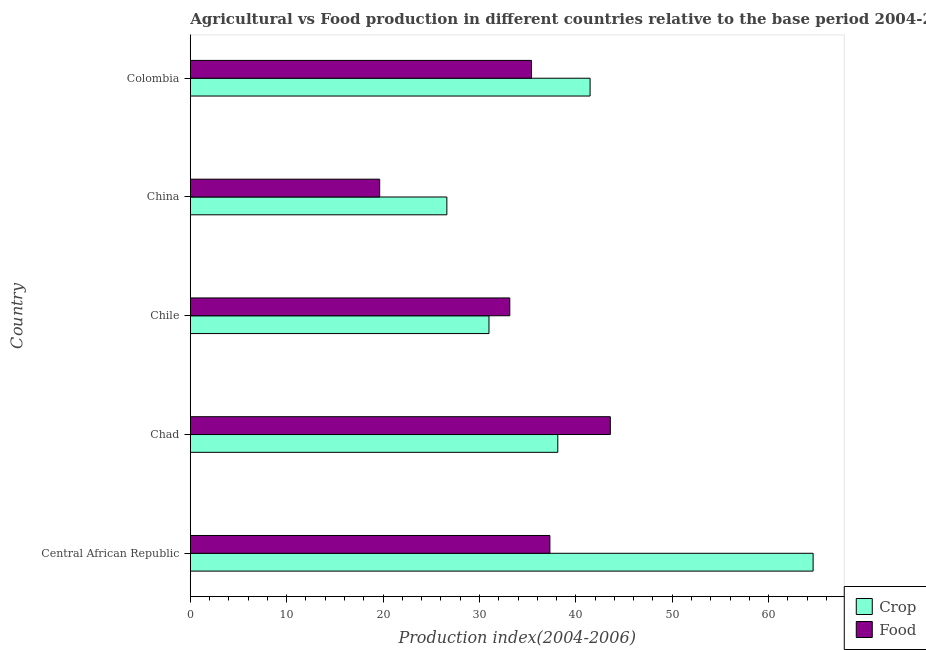How many different coloured bars are there?
Offer a very short reply. 2. How many groups of bars are there?
Provide a short and direct response. 5. Are the number of bars on each tick of the Y-axis equal?
Keep it short and to the point. Yes. What is the label of the 5th group of bars from the top?
Your answer should be compact. Central African Republic. In how many cases, is the number of bars for a given country not equal to the number of legend labels?
Make the answer very short. 0. What is the crop production index in Central African Republic?
Provide a succinct answer. 64.62. Across all countries, what is the maximum food production index?
Offer a very short reply. 43.58. Across all countries, what is the minimum crop production index?
Offer a very short reply. 26.62. In which country was the food production index maximum?
Give a very brief answer. Chad. What is the total food production index in the graph?
Keep it short and to the point. 169.09. What is the difference between the crop production index in Chad and that in China?
Your answer should be compact. 11.51. What is the difference between the crop production index in China and the food production index in Chile?
Make the answer very short. -6.53. What is the average crop production index per country?
Ensure brevity in your answer.  40.37. What is the difference between the crop production index and food production index in Chad?
Your answer should be compact. -5.45. What is the ratio of the food production index in Chile to that in China?
Ensure brevity in your answer.  1.69. What is the difference between the highest and the second highest food production index?
Your answer should be compact. 6.27. What is the difference between the highest and the lowest food production index?
Your answer should be very brief. 23.93. Is the sum of the crop production index in Chad and Chile greater than the maximum food production index across all countries?
Provide a succinct answer. Yes. What does the 2nd bar from the top in Chile represents?
Offer a terse response. Crop. What does the 1st bar from the bottom in Central African Republic represents?
Keep it short and to the point. Crop. How many bars are there?
Your answer should be very brief. 10. How many countries are there in the graph?
Your response must be concise. 5. What is the difference between two consecutive major ticks on the X-axis?
Provide a succinct answer. 10. Are the values on the major ticks of X-axis written in scientific E-notation?
Your answer should be very brief. No. Does the graph contain any zero values?
Your answer should be compact. No. Does the graph contain grids?
Ensure brevity in your answer.  No. Where does the legend appear in the graph?
Provide a succinct answer. Bottom right. How are the legend labels stacked?
Give a very brief answer. Vertical. What is the title of the graph?
Your answer should be compact. Agricultural vs Food production in different countries relative to the base period 2004-2006. What is the label or title of the X-axis?
Provide a succinct answer. Production index(2004-2006). What is the Production index(2004-2006) of Crop in Central African Republic?
Your answer should be compact. 64.62. What is the Production index(2004-2006) in Food in Central African Republic?
Your answer should be very brief. 37.31. What is the Production index(2004-2006) in Crop in Chad?
Ensure brevity in your answer.  38.13. What is the Production index(2004-2006) of Food in Chad?
Your answer should be very brief. 43.58. What is the Production index(2004-2006) in Crop in Chile?
Give a very brief answer. 30.99. What is the Production index(2004-2006) in Food in Chile?
Your answer should be compact. 33.15. What is the Production index(2004-2006) in Crop in China?
Your response must be concise. 26.62. What is the Production index(2004-2006) in Food in China?
Give a very brief answer. 19.65. What is the Production index(2004-2006) in Crop in Colombia?
Ensure brevity in your answer.  41.48. What is the Production index(2004-2006) of Food in Colombia?
Offer a terse response. 35.4. Across all countries, what is the maximum Production index(2004-2006) of Crop?
Make the answer very short. 64.62. Across all countries, what is the maximum Production index(2004-2006) in Food?
Your answer should be very brief. 43.58. Across all countries, what is the minimum Production index(2004-2006) in Crop?
Ensure brevity in your answer.  26.62. Across all countries, what is the minimum Production index(2004-2006) in Food?
Provide a succinct answer. 19.65. What is the total Production index(2004-2006) in Crop in the graph?
Keep it short and to the point. 201.84. What is the total Production index(2004-2006) of Food in the graph?
Make the answer very short. 169.09. What is the difference between the Production index(2004-2006) in Crop in Central African Republic and that in Chad?
Provide a short and direct response. 26.49. What is the difference between the Production index(2004-2006) of Food in Central African Republic and that in Chad?
Ensure brevity in your answer.  -6.27. What is the difference between the Production index(2004-2006) in Crop in Central African Republic and that in Chile?
Make the answer very short. 33.63. What is the difference between the Production index(2004-2006) in Food in Central African Republic and that in Chile?
Give a very brief answer. 4.16. What is the difference between the Production index(2004-2006) in Crop in Central African Republic and that in China?
Keep it short and to the point. 38. What is the difference between the Production index(2004-2006) in Food in Central African Republic and that in China?
Your response must be concise. 17.66. What is the difference between the Production index(2004-2006) in Crop in Central African Republic and that in Colombia?
Your answer should be very brief. 23.14. What is the difference between the Production index(2004-2006) of Food in Central African Republic and that in Colombia?
Your response must be concise. 1.91. What is the difference between the Production index(2004-2006) in Crop in Chad and that in Chile?
Provide a short and direct response. 7.14. What is the difference between the Production index(2004-2006) in Food in Chad and that in Chile?
Your answer should be very brief. 10.43. What is the difference between the Production index(2004-2006) of Crop in Chad and that in China?
Your answer should be compact. 11.51. What is the difference between the Production index(2004-2006) in Food in Chad and that in China?
Provide a short and direct response. 23.93. What is the difference between the Production index(2004-2006) in Crop in Chad and that in Colombia?
Your answer should be very brief. -3.35. What is the difference between the Production index(2004-2006) in Food in Chad and that in Colombia?
Your answer should be compact. 8.18. What is the difference between the Production index(2004-2006) of Crop in Chile and that in China?
Ensure brevity in your answer.  4.37. What is the difference between the Production index(2004-2006) of Crop in Chile and that in Colombia?
Provide a short and direct response. -10.49. What is the difference between the Production index(2004-2006) of Food in Chile and that in Colombia?
Provide a succinct answer. -2.25. What is the difference between the Production index(2004-2006) of Crop in China and that in Colombia?
Your answer should be very brief. -14.86. What is the difference between the Production index(2004-2006) of Food in China and that in Colombia?
Make the answer very short. -15.75. What is the difference between the Production index(2004-2006) in Crop in Central African Republic and the Production index(2004-2006) in Food in Chad?
Provide a succinct answer. 21.04. What is the difference between the Production index(2004-2006) in Crop in Central African Republic and the Production index(2004-2006) in Food in Chile?
Give a very brief answer. 31.47. What is the difference between the Production index(2004-2006) in Crop in Central African Republic and the Production index(2004-2006) in Food in China?
Ensure brevity in your answer.  44.97. What is the difference between the Production index(2004-2006) in Crop in Central African Republic and the Production index(2004-2006) in Food in Colombia?
Offer a terse response. 29.22. What is the difference between the Production index(2004-2006) in Crop in Chad and the Production index(2004-2006) in Food in Chile?
Provide a short and direct response. 4.98. What is the difference between the Production index(2004-2006) in Crop in Chad and the Production index(2004-2006) in Food in China?
Offer a very short reply. 18.48. What is the difference between the Production index(2004-2006) of Crop in Chad and the Production index(2004-2006) of Food in Colombia?
Offer a terse response. 2.73. What is the difference between the Production index(2004-2006) in Crop in Chile and the Production index(2004-2006) in Food in China?
Ensure brevity in your answer.  11.34. What is the difference between the Production index(2004-2006) in Crop in Chile and the Production index(2004-2006) in Food in Colombia?
Provide a short and direct response. -4.41. What is the difference between the Production index(2004-2006) in Crop in China and the Production index(2004-2006) in Food in Colombia?
Offer a terse response. -8.78. What is the average Production index(2004-2006) in Crop per country?
Your answer should be very brief. 40.37. What is the average Production index(2004-2006) of Food per country?
Your answer should be compact. 33.82. What is the difference between the Production index(2004-2006) of Crop and Production index(2004-2006) of Food in Central African Republic?
Provide a short and direct response. 27.31. What is the difference between the Production index(2004-2006) of Crop and Production index(2004-2006) of Food in Chad?
Give a very brief answer. -5.45. What is the difference between the Production index(2004-2006) of Crop and Production index(2004-2006) of Food in Chile?
Keep it short and to the point. -2.16. What is the difference between the Production index(2004-2006) in Crop and Production index(2004-2006) in Food in China?
Offer a very short reply. 6.97. What is the difference between the Production index(2004-2006) in Crop and Production index(2004-2006) in Food in Colombia?
Your answer should be very brief. 6.08. What is the ratio of the Production index(2004-2006) of Crop in Central African Republic to that in Chad?
Your answer should be compact. 1.69. What is the ratio of the Production index(2004-2006) in Food in Central African Republic to that in Chad?
Make the answer very short. 0.86. What is the ratio of the Production index(2004-2006) in Crop in Central African Republic to that in Chile?
Provide a short and direct response. 2.09. What is the ratio of the Production index(2004-2006) in Food in Central African Republic to that in Chile?
Give a very brief answer. 1.13. What is the ratio of the Production index(2004-2006) in Crop in Central African Republic to that in China?
Make the answer very short. 2.43. What is the ratio of the Production index(2004-2006) in Food in Central African Republic to that in China?
Keep it short and to the point. 1.9. What is the ratio of the Production index(2004-2006) in Crop in Central African Republic to that in Colombia?
Provide a short and direct response. 1.56. What is the ratio of the Production index(2004-2006) in Food in Central African Republic to that in Colombia?
Ensure brevity in your answer.  1.05. What is the ratio of the Production index(2004-2006) of Crop in Chad to that in Chile?
Offer a terse response. 1.23. What is the ratio of the Production index(2004-2006) of Food in Chad to that in Chile?
Give a very brief answer. 1.31. What is the ratio of the Production index(2004-2006) in Crop in Chad to that in China?
Offer a terse response. 1.43. What is the ratio of the Production index(2004-2006) of Food in Chad to that in China?
Ensure brevity in your answer.  2.22. What is the ratio of the Production index(2004-2006) in Crop in Chad to that in Colombia?
Offer a very short reply. 0.92. What is the ratio of the Production index(2004-2006) of Food in Chad to that in Colombia?
Offer a very short reply. 1.23. What is the ratio of the Production index(2004-2006) in Crop in Chile to that in China?
Keep it short and to the point. 1.16. What is the ratio of the Production index(2004-2006) of Food in Chile to that in China?
Give a very brief answer. 1.69. What is the ratio of the Production index(2004-2006) of Crop in Chile to that in Colombia?
Keep it short and to the point. 0.75. What is the ratio of the Production index(2004-2006) in Food in Chile to that in Colombia?
Keep it short and to the point. 0.94. What is the ratio of the Production index(2004-2006) in Crop in China to that in Colombia?
Ensure brevity in your answer.  0.64. What is the ratio of the Production index(2004-2006) in Food in China to that in Colombia?
Provide a succinct answer. 0.56. What is the difference between the highest and the second highest Production index(2004-2006) of Crop?
Your answer should be compact. 23.14. What is the difference between the highest and the second highest Production index(2004-2006) of Food?
Make the answer very short. 6.27. What is the difference between the highest and the lowest Production index(2004-2006) in Food?
Offer a terse response. 23.93. 